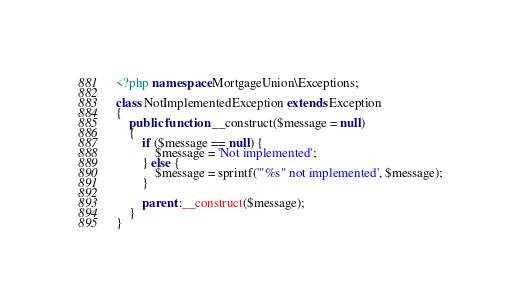<code> <loc_0><loc_0><loc_500><loc_500><_PHP_><?php namespace MortgageUnion\Exceptions;

class NotImplementedException extends Exception
{
    public function __construct($message = null)
    {
        if ($message == null) {
            $message = 'Not implemented';
        } else {
            $message = sprintf('"%s" not implemented', $message);
        }

        parent::__construct($message);
    }
}
</code> 